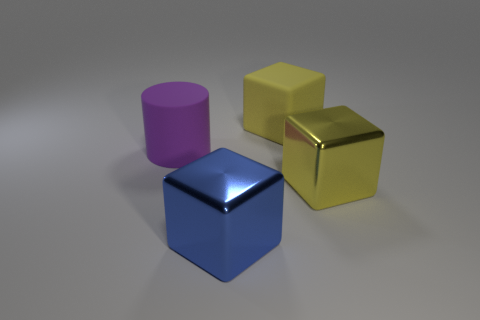Add 1 tiny gray metallic blocks. How many objects exist? 5 Subtract all blocks. How many objects are left? 1 Subtract all green cylinders. Subtract all large yellow blocks. How many objects are left? 2 Add 1 purple matte cylinders. How many purple matte cylinders are left? 2 Add 1 big metal blocks. How many big metal blocks exist? 3 Subtract 0 green cubes. How many objects are left? 4 